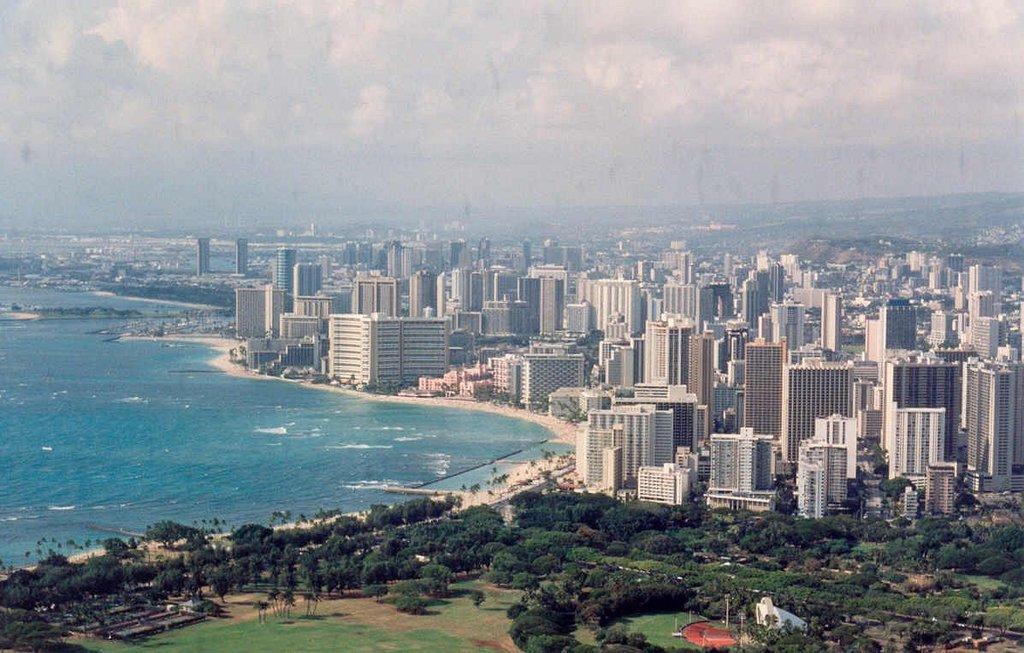Can you describe this image briefly? In this picture we can see many buildings on the right side. There is water on the left side. We can see many trees from left to right. Some grass is visible on the ground. We can see a white object and few poles. Sky is cloudy. 